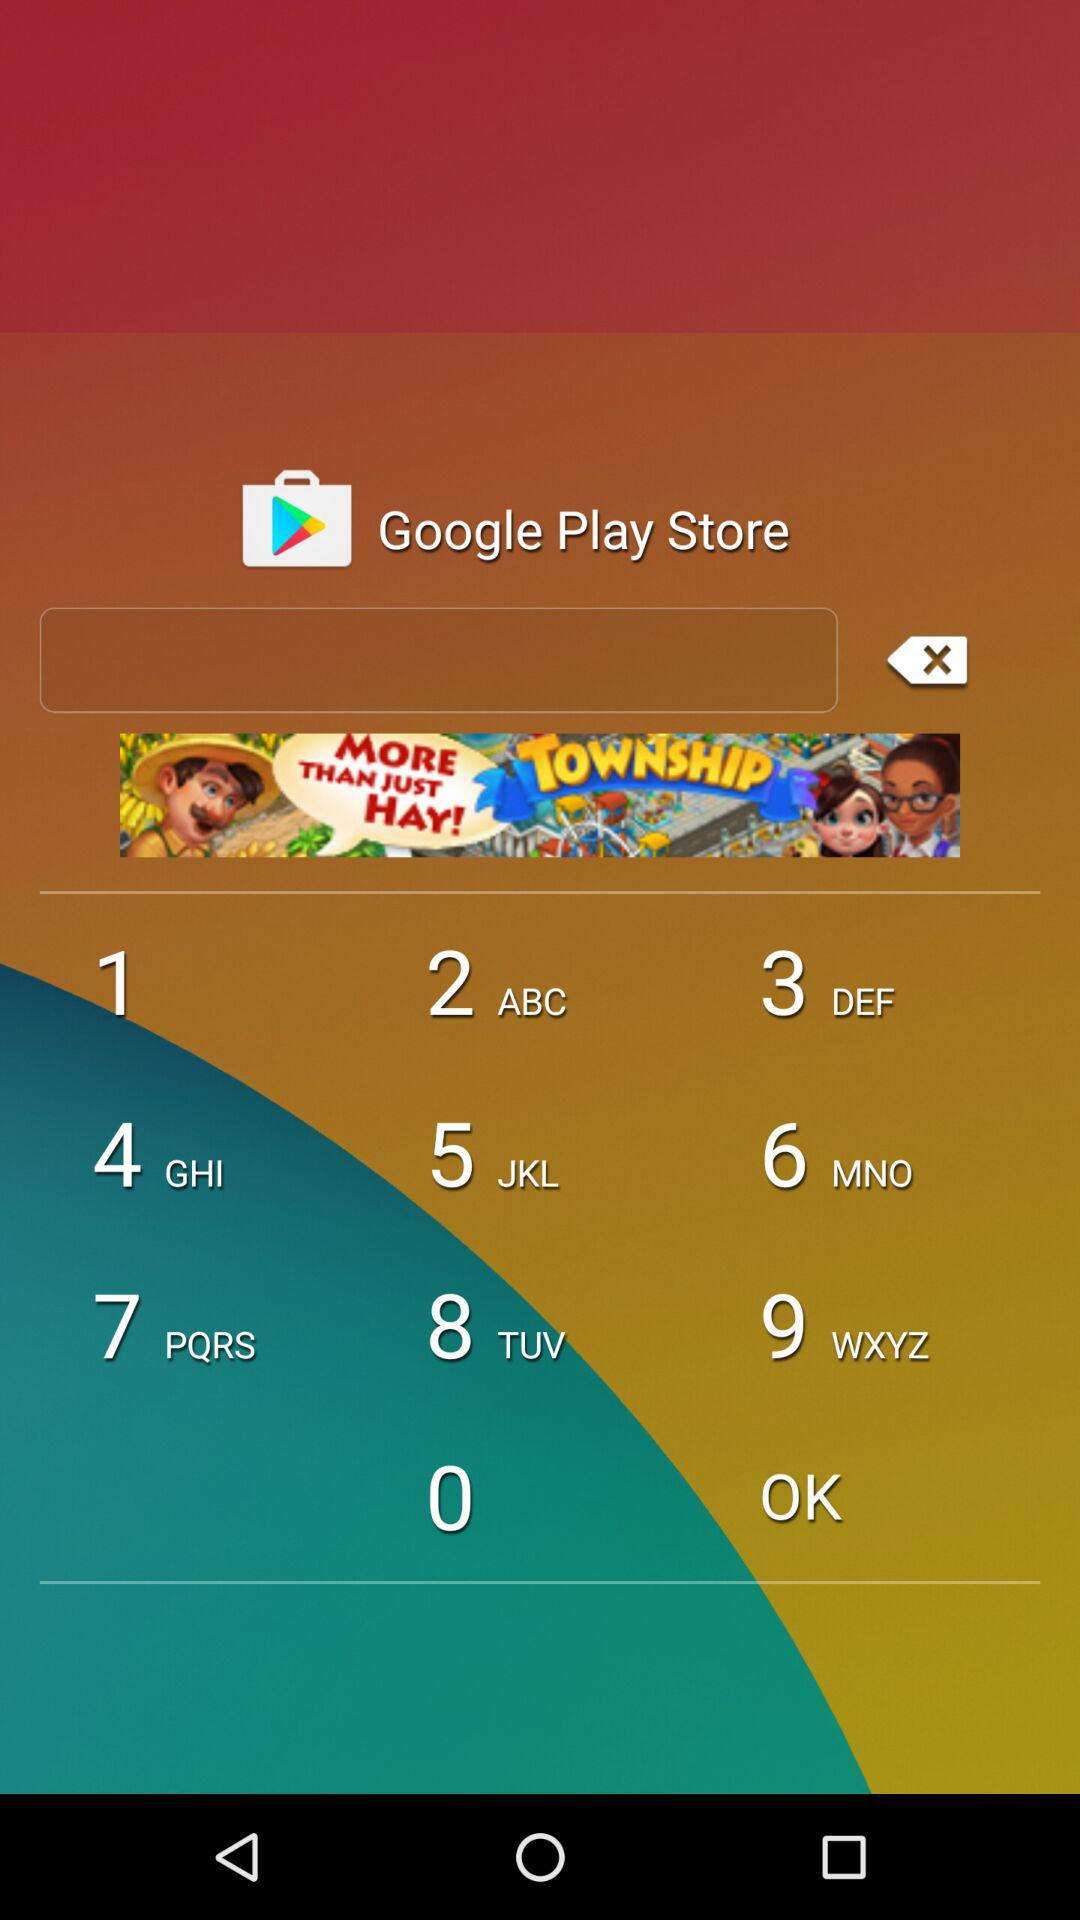What is the email address?
When the provided information is insufficient, respond with <no answer>. <no answer> 